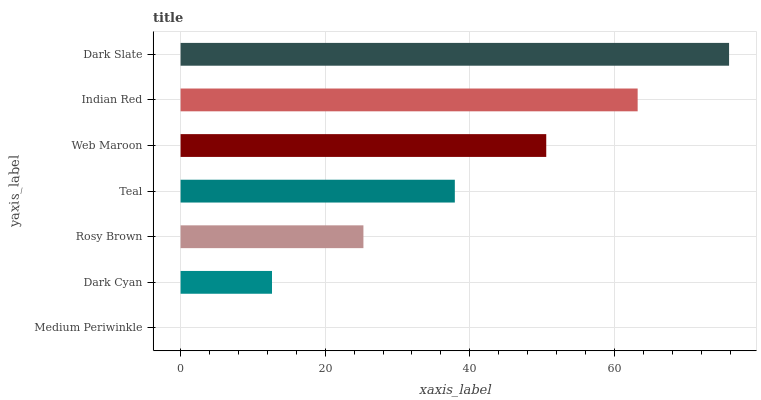Is Medium Periwinkle the minimum?
Answer yes or no. Yes. Is Dark Slate the maximum?
Answer yes or no. Yes. Is Dark Cyan the minimum?
Answer yes or no. No. Is Dark Cyan the maximum?
Answer yes or no. No. Is Dark Cyan greater than Medium Periwinkle?
Answer yes or no. Yes. Is Medium Periwinkle less than Dark Cyan?
Answer yes or no. Yes. Is Medium Periwinkle greater than Dark Cyan?
Answer yes or no. No. Is Dark Cyan less than Medium Periwinkle?
Answer yes or no. No. Is Teal the high median?
Answer yes or no. Yes. Is Teal the low median?
Answer yes or no. Yes. Is Dark Slate the high median?
Answer yes or no. No. Is Medium Periwinkle the low median?
Answer yes or no. No. 